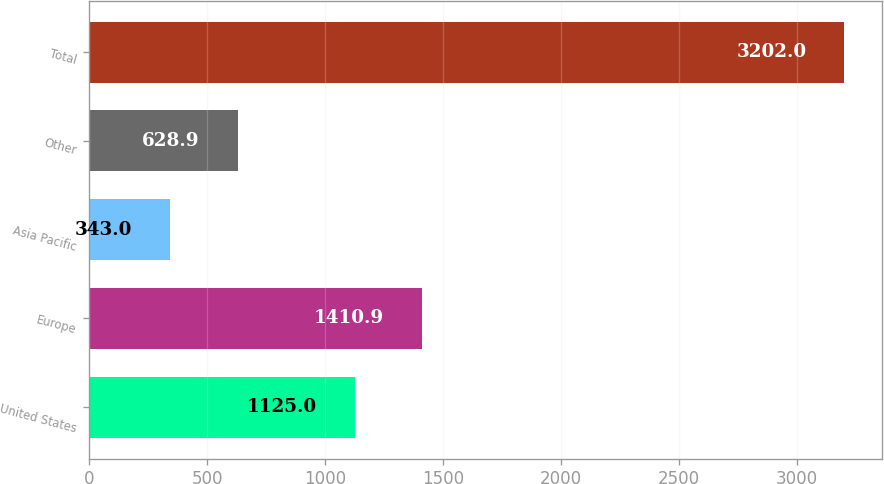<chart> <loc_0><loc_0><loc_500><loc_500><bar_chart><fcel>United States<fcel>Europe<fcel>Asia Pacific<fcel>Other<fcel>Total<nl><fcel>1125<fcel>1410.9<fcel>343<fcel>628.9<fcel>3202<nl></chart> 